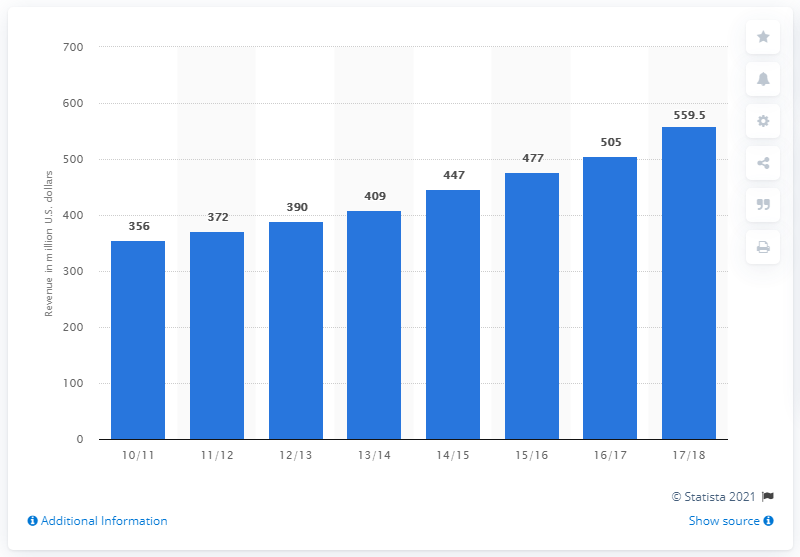Identify some key points in this picture. In the 2017/2018 season, the total sponsorship revenue generated by the National Hockey League (NHL) globally was 559.5 million U.S. dollars. 